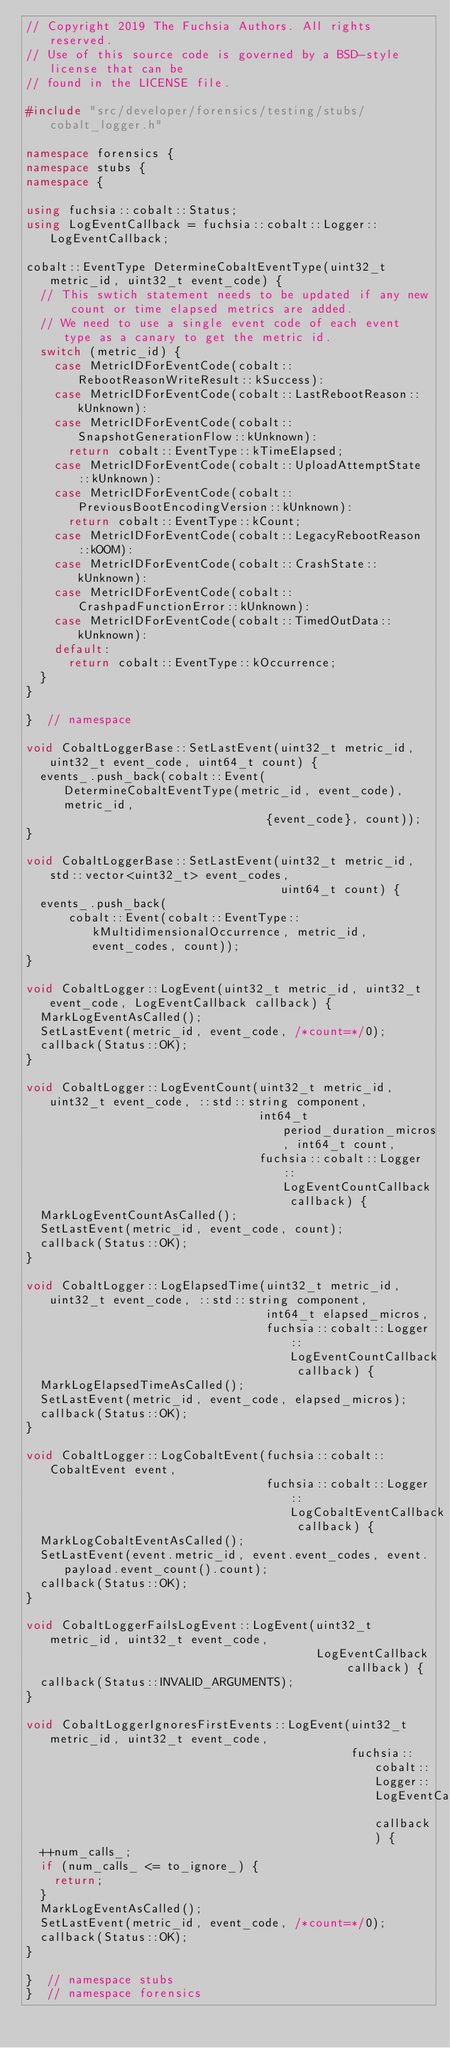<code> <loc_0><loc_0><loc_500><loc_500><_C++_>// Copyright 2019 The Fuchsia Authors. All rights reserved.
// Use of this source code is governed by a BSD-style license that can be
// found in the LICENSE file.

#include "src/developer/forensics/testing/stubs/cobalt_logger.h"

namespace forensics {
namespace stubs {
namespace {

using fuchsia::cobalt::Status;
using LogEventCallback = fuchsia::cobalt::Logger::LogEventCallback;

cobalt::EventType DetermineCobaltEventType(uint32_t metric_id, uint32_t event_code) {
  // This swtich statement needs to be updated if any new count or time elapsed metrics are added.
  // We need to use a single event code of each event type as a canary to get the metric id.
  switch (metric_id) {
    case MetricIDForEventCode(cobalt::RebootReasonWriteResult::kSuccess):
    case MetricIDForEventCode(cobalt::LastRebootReason::kUnknown):
    case MetricIDForEventCode(cobalt::SnapshotGenerationFlow::kUnknown):
      return cobalt::EventType::kTimeElapsed;
    case MetricIDForEventCode(cobalt::UploadAttemptState::kUnknown):
    case MetricIDForEventCode(cobalt::PreviousBootEncodingVersion::kUnknown):
      return cobalt::EventType::kCount;
    case MetricIDForEventCode(cobalt::LegacyRebootReason::kOOM):
    case MetricIDForEventCode(cobalt::CrashState::kUnknown):
    case MetricIDForEventCode(cobalt::CrashpadFunctionError::kUnknown):
    case MetricIDForEventCode(cobalt::TimedOutData::kUnknown):
    default:
      return cobalt::EventType::kOccurrence;
  }
}

}  // namespace

void CobaltLoggerBase::SetLastEvent(uint32_t metric_id, uint32_t event_code, uint64_t count) {
  events_.push_back(cobalt::Event(DetermineCobaltEventType(metric_id, event_code), metric_id,
                                  {event_code}, count));
}

void CobaltLoggerBase::SetLastEvent(uint32_t metric_id, std::vector<uint32_t> event_codes,
                                    uint64_t count) {
  events_.push_back(
      cobalt::Event(cobalt::EventType::kMultidimensionalOccurrence, metric_id, event_codes, count));
}

void CobaltLogger::LogEvent(uint32_t metric_id, uint32_t event_code, LogEventCallback callback) {
  MarkLogEventAsCalled();
  SetLastEvent(metric_id, event_code, /*count=*/0);
  callback(Status::OK);
}

void CobaltLogger::LogEventCount(uint32_t metric_id, uint32_t event_code, ::std::string component,
                                 int64_t period_duration_micros, int64_t count,
                                 fuchsia::cobalt::Logger::LogEventCountCallback callback) {
  MarkLogEventCountAsCalled();
  SetLastEvent(metric_id, event_code, count);
  callback(Status::OK);
}

void CobaltLogger::LogElapsedTime(uint32_t metric_id, uint32_t event_code, ::std::string component,
                                  int64_t elapsed_micros,
                                  fuchsia::cobalt::Logger::LogEventCountCallback callback) {
  MarkLogElapsedTimeAsCalled();
  SetLastEvent(metric_id, event_code, elapsed_micros);
  callback(Status::OK);
}

void CobaltLogger::LogCobaltEvent(fuchsia::cobalt::CobaltEvent event,
                                  fuchsia::cobalt::Logger::LogCobaltEventCallback callback) {
  MarkLogCobaltEventAsCalled();
  SetLastEvent(event.metric_id, event.event_codes, event.payload.event_count().count);
  callback(Status::OK);
}

void CobaltLoggerFailsLogEvent::LogEvent(uint32_t metric_id, uint32_t event_code,
                                         LogEventCallback callback) {
  callback(Status::INVALID_ARGUMENTS);
}

void CobaltLoggerIgnoresFirstEvents::LogEvent(uint32_t metric_id, uint32_t event_code,
                                              fuchsia::cobalt::Logger::LogEventCallback callback) {
  ++num_calls_;
  if (num_calls_ <= to_ignore_) {
    return;
  }
  MarkLogEventAsCalled();
  SetLastEvent(metric_id, event_code, /*count=*/0);
  callback(Status::OK);
}

}  // namespace stubs
}  // namespace forensics
</code> 